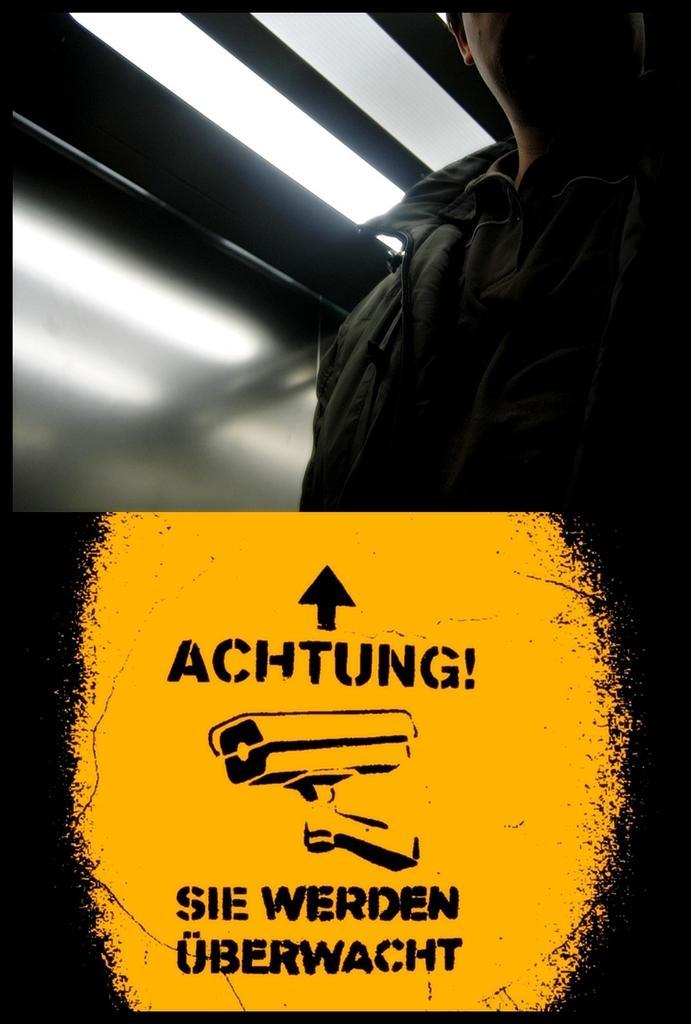Could you give a brief overview of what you see in this image? In this picture there is a man who is wearing a jacket. At the bottom I can see the poster which showing the camera. At the top I can see the tube-light. 